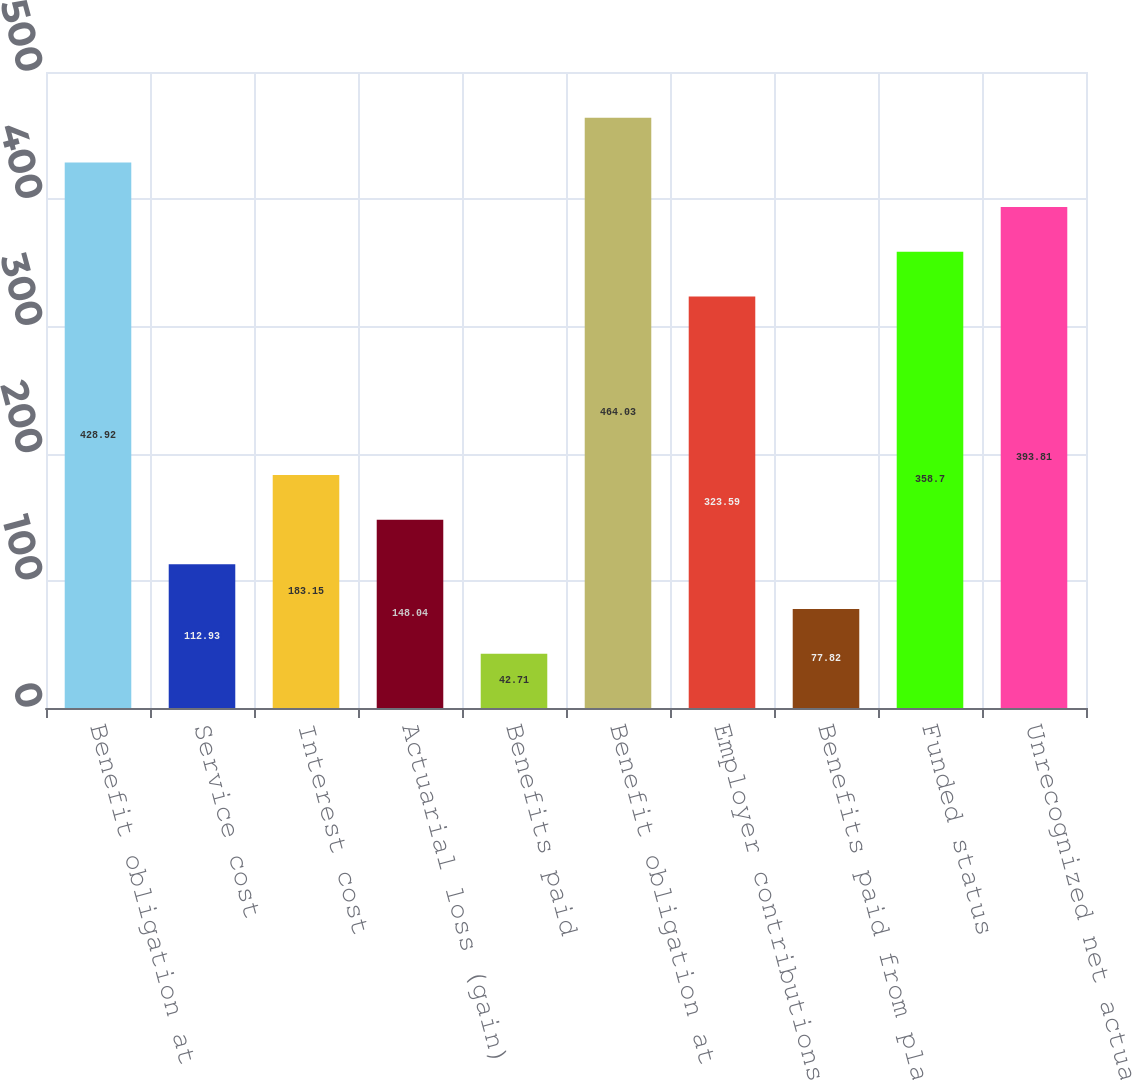Convert chart to OTSL. <chart><loc_0><loc_0><loc_500><loc_500><bar_chart><fcel>Benefit obligation at<fcel>Service cost<fcel>Interest cost<fcel>Actuarial loss (gain)<fcel>Benefits paid<fcel>Benefit obligation at end of<fcel>Employer contributions<fcel>Benefits paid from plan assets<fcel>Funded status<fcel>Unrecognized net actuarial<nl><fcel>428.92<fcel>112.93<fcel>183.15<fcel>148.04<fcel>42.71<fcel>464.03<fcel>323.59<fcel>77.82<fcel>358.7<fcel>393.81<nl></chart> 